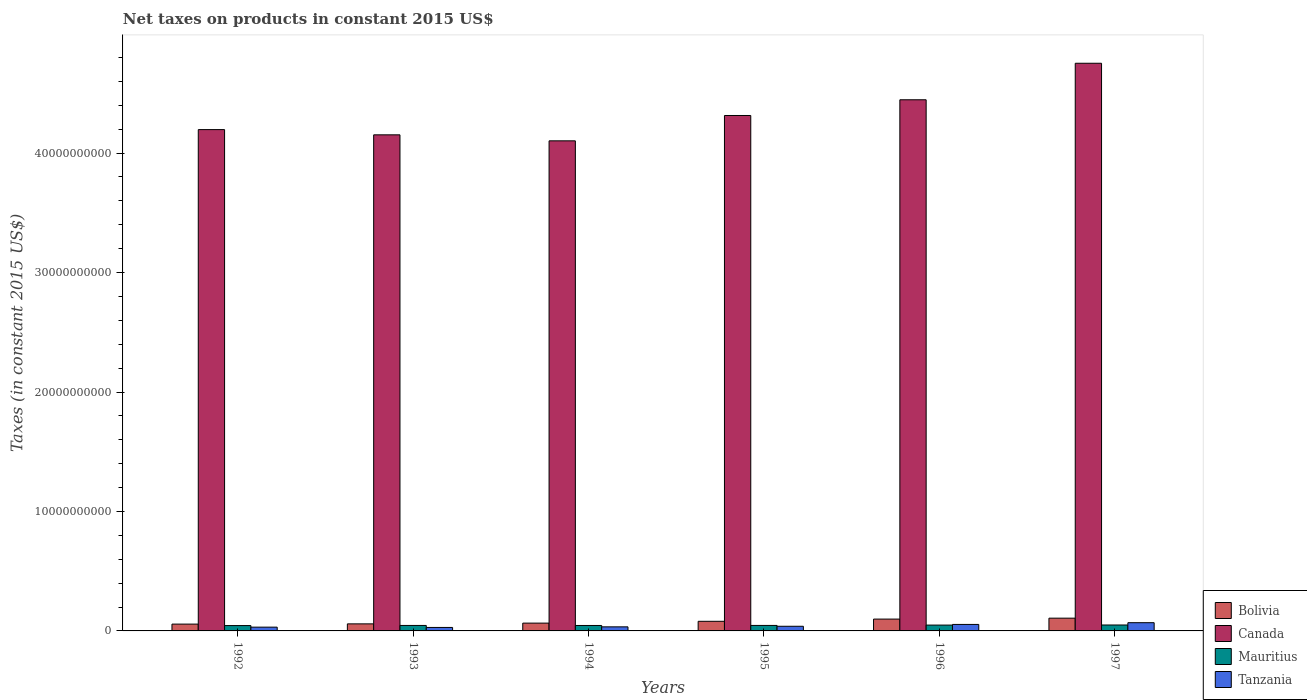How many groups of bars are there?
Your answer should be compact. 6. Are the number of bars on each tick of the X-axis equal?
Offer a very short reply. Yes. What is the label of the 6th group of bars from the left?
Ensure brevity in your answer.  1997. What is the net taxes on products in Bolivia in 1996?
Your answer should be compact. 9.90e+08. Across all years, what is the maximum net taxes on products in Mauritius?
Keep it short and to the point. 4.96e+08. Across all years, what is the minimum net taxes on products in Mauritius?
Provide a short and direct response. 4.48e+08. In which year was the net taxes on products in Bolivia maximum?
Your answer should be very brief. 1997. In which year was the net taxes on products in Bolivia minimum?
Offer a terse response. 1992. What is the total net taxes on products in Bolivia in the graph?
Your response must be concise. 4.68e+09. What is the difference between the net taxes on products in Bolivia in 1992 and that in 1997?
Keep it short and to the point. -4.96e+08. What is the difference between the net taxes on products in Mauritius in 1992 and the net taxes on products in Bolivia in 1997?
Your answer should be very brief. -6.20e+08. What is the average net taxes on products in Tanzania per year?
Provide a succinct answer. 4.28e+08. In the year 1997, what is the difference between the net taxes on products in Canada and net taxes on products in Tanzania?
Ensure brevity in your answer.  4.68e+1. In how many years, is the net taxes on products in Canada greater than 34000000000 US$?
Ensure brevity in your answer.  6. What is the ratio of the net taxes on products in Canada in 1994 to that in 1996?
Make the answer very short. 0.92. What is the difference between the highest and the second highest net taxes on products in Bolivia?
Provide a succinct answer. 7.73e+07. What is the difference between the highest and the lowest net taxes on products in Mauritius?
Keep it short and to the point. 4.88e+07. Is the sum of the net taxes on products in Mauritius in 1995 and 1996 greater than the maximum net taxes on products in Tanzania across all years?
Offer a very short reply. Yes. Is it the case that in every year, the sum of the net taxes on products in Tanzania and net taxes on products in Canada is greater than the sum of net taxes on products in Mauritius and net taxes on products in Bolivia?
Your response must be concise. Yes. What does the 2nd bar from the left in 1997 represents?
Your answer should be compact. Canada. Is it the case that in every year, the sum of the net taxes on products in Bolivia and net taxes on products in Tanzania is greater than the net taxes on products in Mauritius?
Provide a short and direct response. Yes. How many bars are there?
Ensure brevity in your answer.  24. Are all the bars in the graph horizontal?
Your response must be concise. No. What is the difference between two consecutive major ticks on the Y-axis?
Your answer should be compact. 1.00e+1. Does the graph contain any zero values?
Provide a succinct answer. No. Does the graph contain grids?
Your answer should be compact. No. Where does the legend appear in the graph?
Offer a very short reply. Bottom right. How are the legend labels stacked?
Give a very brief answer. Vertical. What is the title of the graph?
Keep it short and to the point. Net taxes on products in constant 2015 US$. What is the label or title of the Y-axis?
Give a very brief answer. Taxes (in constant 2015 US$). What is the Taxes (in constant 2015 US$) in Bolivia in 1992?
Your answer should be compact. 5.71e+08. What is the Taxes (in constant 2015 US$) of Canada in 1992?
Give a very brief answer. 4.20e+1. What is the Taxes (in constant 2015 US$) of Mauritius in 1992?
Give a very brief answer. 4.48e+08. What is the Taxes (in constant 2015 US$) in Tanzania in 1992?
Offer a terse response. 3.16e+08. What is the Taxes (in constant 2015 US$) in Bolivia in 1993?
Give a very brief answer. 5.90e+08. What is the Taxes (in constant 2015 US$) in Canada in 1993?
Your answer should be very brief. 4.15e+1. What is the Taxes (in constant 2015 US$) in Mauritius in 1993?
Your answer should be very brief. 4.58e+08. What is the Taxes (in constant 2015 US$) of Tanzania in 1993?
Ensure brevity in your answer.  2.91e+08. What is the Taxes (in constant 2015 US$) in Bolivia in 1994?
Your answer should be compact. 6.54e+08. What is the Taxes (in constant 2015 US$) in Canada in 1994?
Provide a short and direct response. 4.10e+1. What is the Taxes (in constant 2015 US$) in Mauritius in 1994?
Keep it short and to the point. 4.55e+08. What is the Taxes (in constant 2015 US$) of Tanzania in 1994?
Offer a very short reply. 3.41e+08. What is the Taxes (in constant 2015 US$) of Bolivia in 1995?
Ensure brevity in your answer.  8.05e+08. What is the Taxes (in constant 2015 US$) in Canada in 1995?
Keep it short and to the point. 4.31e+1. What is the Taxes (in constant 2015 US$) of Mauritius in 1995?
Keep it short and to the point. 4.59e+08. What is the Taxes (in constant 2015 US$) of Tanzania in 1995?
Ensure brevity in your answer.  3.89e+08. What is the Taxes (in constant 2015 US$) in Bolivia in 1996?
Your answer should be compact. 9.90e+08. What is the Taxes (in constant 2015 US$) of Canada in 1996?
Your response must be concise. 4.45e+1. What is the Taxes (in constant 2015 US$) of Mauritius in 1996?
Your answer should be compact. 4.89e+08. What is the Taxes (in constant 2015 US$) in Tanzania in 1996?
Keep it short and to the point. 5.43e+08. What is the Taxes (in constant 2015 US$) in Bolivia in 1997?
Offer a very short reply. 1.07e+09. What is the Taxes (in constant 2015 US$) of Canada in 1997?
Give a very brief answer. 4.75e+1. What is the Taxes (in constant 2015 US$) in Mauritius in 1997?
Provide a short and direct response. 4.96e+08. What is the Taxes (in constant 2015 US$) in Tanzania in 1997?
Ensure brevity in your answer.  6.89e+08. Across all years, what is the maximum Taxes (in constant 2015 US$) in Bolivia?
Provide a short and direct response. 1.07e+09. Across all years, what is the maximum Taxes (in constant 2015 US$) of Canada?
Provide a succinct answer. 4.75e+1. Across all years, what is the maximum Taxes (in constant 2015 US$) in Mauritius?
Ensure brevity in your answer.  4.96e+08. Across all years, what is the maximum Taxes (in constant 2015 US$) of Tanzania?
Your answer should be very brief. 6.89e+08. Across all years, what is the minimum Taxes (in constant 2015 US$) in Bolivia?
Your answer should be compact. 5.71e+08. Across all years, what is the minimum Taxes (in constant 2015 US$) of Canada?
Ensure brevity in your answer.  4.10e+1. Across all years, what is the minimum Taxes (in constant 2015 US$) in Mauritius?
Keep it short and to the point. 4.48e+08. Across all years, what is the minimum Taxes (in constant 2015 US$) of Tanzania?
Give a very brief answer. 2.91e+08. What is the total Taxes (in constant 2015 US$) in Bolivia in the graph?
Keep it short and to the point. 4.68e+09. What is the total Taxes (in constant 2015 US$) of Canada in the graph?
Keep it short and to the point. 2.60e+11. What is the total Taxes (in constant 2015 US$) in Mauritius in the graph?
Ensure brevity in your answer.  2.81e+09. What is the total Taxes (in constant 2015 US$) in Tanzania in the graph?
Offer a terse response. 2.57e+09. What is the difference between the Taxes (in constant 2015 US$) of Bolivia in 1992 and that in 1993?
Offer a very short reply. -1.90e+07. What is the difference between the Taxes (in constant 2015 US$) of Canada in 1992 and that in 1993?
Make the answer very short. 4.37e+08. What is the difference between the Taxes (in constant 2015 US$) of Mauritius in 1992 and that in 1993?
Offer a terse response. -1.08e+07. What is the difference between the Taxes (in constant 2015 US$) of Tanzania in 1992 and that in 1993?
Offer a terse response. 2.50e+07. What is the difference between the Taxes (in constant 2015 US$) of Bolivia in 1992 and that in 1994?
Provide a succinct answer. -8.23e+07. What is the difference between the Taxes (in constant 2015 US$) of Canada in 1992 and that in 1994?
Provide a succinct answer. 9.40e+08. What is the difference between the Taxes (in constant 2015 US$) of Mauritius in 1992 and that in 1994?
Your answer should be compact. -7.79e+06. What is the difference between the Taxes (in constant 2015 US$) in Tanzania in 1992 and that in 1994?
Your response must be concise. -2.49e+07. What is the difference between the Taxes (in constant 2015 US$) in Bolivia in 1992 and that in 1995?
Provide a short and direct response. -2.34e+08. What is the difference between the Taxes (in constant 2015 US$) in Canada in 1992 and that in 1995?
Your response must be concise. -1.18e+09. What is the difference between the Taxes (in constant 2015 US$) in Mauritius in 1992 and that in 1995?
Offer a terse response. -1.19e+07. What is the difference between the Taxes (in constant 2015 US$) of Tanzania in 1992 and that in 1995?
Give a very brief answer. -7.39e+07. What is the difference between the Taxes (in constant 2015 US$) in Bolivia in 1992 and that in 1996?
Ensure brevity in your answer.  -4.19e+08. What is the difference between the Taxes (in constant 2015 US$) of Canada in 1992 and that in 1996?
Offer a terse response. -2.50e+09. What is the difference between the Taxes (in constant 2015 US$) of Mauritius in 1992 and that in 1996?
Give a very brief answer. -4.10e+07. What is the difference between the Taxes (in constant 2015 US$) in Tanzania in 1992 and that in 1996?
Provide a succinct answer. -2.28e+08. What is the difference between the Taxes (in constant 2015 US$) of Bolivia in 1992 and that in 1997?
Provide a short and direct response. -4.96e+08. What is the difference between the Taxes (in constant 2015 US$) of Canada in 1992 and that in 1997?
Offer a very short reply. -5.55e+09. What is the difference between the Taxes (in constant 2015 US$) of Mauritius in 1992 and that in 1997?
Your response must be concise. -4.88e+07. What is the difference between the Taxes (in constant 2015 US$) of Tanzania in 1992 and that in 1997?
Ensure brevity in your answer.  -3.74e+08. What is the difference between the Taxes (in constant 2015 US$) of Bolivia in 1993 and that in 1994?
Your response must be concise. -6.34e+07. What is the difference between the Taxes (in constant 2015 US$) of Canada in 1993 and that in 1994?
Provide a short and direct response. 5.03e+08. What is the difference between the Taxes (in constant 2015 US$) in Mauritius in 1993 and that in 1994?
Your response must be concise. 2.97e+06. What is the difference between the Taxes (in constant 2015 US$) in Tanzania in 1993 and that in 1994?
Your answer should be compact. -4.99e+07. What is the difference between the Taxes (in constant 2015 US$) of Bolivia in 1993 and that in 1995?
Keep it short and to the point. -2.15e+08. What is the difference between the Taxes (in constant 2015 US$) of Canada in 1993 and that in 1995?
Your answer should be compact. -1.62e+09. What is the difference between the Taxes (in constant 2015 US$) in Mauritius in 1993 and that in 1995?
Keep it short and to the point. -1.11e+06. What is the difference between the Taxes (in constant 2015 US$) of Tanzania in 1993 and that in 1995?
Give a very brief answer. -9.89e+07. What is the difference between the Taxes (in constant 2015 US$) of Bolivia in 1993 and that in 1996?
Provide a succinct answer. -4.00e+08. What is the difference between the Taxes (in constant 2015 US$) in Canada in 1993 and that in 1996?
Your answer should be very brief. -2.93e+09. What is the difference between the Taxes (in constant 2015 US$) of Mauritius in 1993 and that in 1996?
Offer a terse response. -3.02e+07. What is the difference between the Taxes (in constant 2015 US$) of Tanzania in 1993 and that in 1996?
Make the answer very short. -2.53e+08. What is the difference between the Taxes (in constant 2015 US$) in Bolivia in 1993 and that in 1997?
Provide a succinct answer. -4.77e+08. What is the difference between the Taxes (in constant 2015 US$) of Canada in 1993 and that in 1997?
Make the answer very short. -5.99e+09. What is the difference between the Taxes (in constant 2015 US$) in Mauritius in 1993 and that in 1997?
Make the answer very short. -3.80e+07. What is the difference between the Taxes (in constant 2015 US$) of Tanzania in 1993 and that in 1997?
Your answer should be compact. -3.99e+08. What is the difference between the Taxes (in constant 2015 US$) of Bolivia in 1994 and that in 1995?
Provide a short and direct response. -1.51e+08. What is the difference between the Taxes (in constant 2015 US$) of Canada in 1994 and that in 1995?
Offer a very short reply. -2.12e+09. What is the difference between the Taxes (in constant 2015 US$) in Mauritius in 1994 and that in 1995?
Provide a succinct answer. -4.07e+06. What is the difference between the Taxes (in constant 2015 US$) of Tanzania in 1994 and that in 1995?
Offer a terse response. -4.90e+07. What is the difference between the Taxes (in constant 2015 US$) in Bolivia in 1994 and that in 1996?
Offer a very short reply. -3.37e+08. What is the difference between the Taxes (in constant 2015 US$) in Canada in 1994 and that in 1996?
Offer a terse response. -3.44e+09. What is the difference between the Taxes (in constant 2015 US$) of Mauritius in 1994 and that in 1996?
Offer a very short reply. -3.32e+07. What is the difference between the Taxes (in constant 2015 US$) in Tanzania in 1994 and that in 1996?
Offer a very short reply. -2.03e+08. What is the difference between the Taxes (in constant 2015 US$) of Bolivia in 1994 and that in 1997?
Provide a succinct answer. -4.14e+08. What is the difference between the Taxes (in constant 2015 US$) of Canada in 1994 and that in 1997?
Provide a short and direct response. -6.49e+09. What is the difference between the Taxes (in constant 2015 US$) in Mauritius in 1994 and that in 1997?
Offer a terse response. -4.10e+07. What is the difference between the Taxes (in constant 2015 US$) of Tanzania in 1994 and that in 1997?
Provide a short and direct response. -3.49e+08. What is the difference between the Taxes (in constant 2015 US$) in Bolivia in 1995 and that in 1996?
Provide a succinct answer. -1.85e+08. What is the difference between the Taxes (in constant 2015 US$) of Canada in 1995 and that in 1996?
Offer a very short reply. -1.32e+09. What is the difference between the Taxes (in constant 2015 US$) in Mauritius in 1995 and that in 1996?
Offer a very short reply. -2.91e+07. What is the difference between the Taxes (in constant 2015 US$) in Tanzania in 1995 and that in 1996?
Give a very brief answer. -1.54e+08. What is the difference between the Taxes (in constant 2015 US$) of Bolivia in 1995 and that in 1997?
Give a very brief answer. -2.62e+08. What is the difference between the Taxes (in constant 2015 US$) of Canada in 1995 and that in 1997?
Make the answer very short. -4.37e+09. What is the difference between the Taxes (in constant 2015 US$) of Mauritius in 1995 and that in 1997?
Keep it short and to the point. -3.69e+07. What is the difference between the Taxes (in constant 2015 US$) of Tanzania in 1995 and that in 1997?
Provide a short and direct response. -3.00e+08. What is the difference between the Taxes (in constant 2015 US$) of Bolivia in 1996 and that in 1997?
Keep it short and to the point. -7.73e+07. What is the difference between the Taxes (in constant 2015 US$) of Canada in 1996 and that in 1997?
Your answer should be compact. -3.06e+09. What is the difference between the Taxes (in constant 2015 US$) of Mauritius in 1996 and that in 1997?
Offer a very short reply. -7.79e+06. What is the difference between the Taxes (in constant 2015 US$) of Tanzania in 1996 and that in 1997?
Provide a short and direct response. -1.46e+08. What is the difference between the Taxes (in constant 2015 US$) of Bolivia in 1992 and the Taxes (in constant 2015 US$) of Canada in 1993?
Provide a short and direct response. -4.10e+1. What is the difference between the Taxes (in constant 2015 US$) of Bolivia in 1992 and the Taxes (in constant 2015 US$) of Mauritius in 1993?
Give a very brief answer. 1.13e+08. What is the difference between the Taxes (in constant 2015 US$) in Bolivia in 1992 and the Taxes (in constant 2015 US$) in Tanzania in 1993?
Make the answer very short. 2.81e+08. What is the difference between the Taxes (in constant 2015 US$) in Canada in 1992 and the Taxes (in constant 2015 US$) in Mauritius in 1993?
Give a very brief answer. 4.15e+1. What is the difference between the Taxes (in constant 2015 US$) in Canada in 1992 and the Taxes (in constant 2015 US$) in Tanzania in 1993?
Provide a short and direct response. 4.17e+1. What is the difference between the Taxes (in constant 2015 US$) in Mauritius in 1992 and the Taxes (in constant 2015 US$) in Tanzania in 1993?
Keep it short and to the point. 1.57e+08. What is the difference between the Taxes (in constant 2015 US$) of Bolivia in 1992 and the Taxes (in constant 2015 US$) of Canada in 1994?
Your answer should be compact. -4.05e+1. What is the difference between the Taxes (in constant 2015 US$) in Bolivia in 1992 and the Taxes (in constant 2015 US$) in Mauritius in 1994?
Your answer should be compact. 1.16e+08. What is the difference between the Taxes (in constant 2015 US$) in Bolivia in 1992 and the Taxes (in constant 2015 US$) in Tanzania in 1994?
Ensure brevity in your answer.  2.31e+08. What is the difference between the Taxes (in constant 2015 US$) in Canada in 1992 and the Taxes (in constant 2015 US$) in Mauritius in 1994?
Your response must be concise. 4.15e+1. What is the difference between the Taxes (in constant 2015 US$) in Canada in 1992 and the Taxes (in constant 2015 US$) in Tanzania in 1994?
Give a very brief answer. 4.16e+1. What is the difference between the Taxes (in constant 2015 US$) of Mauritius in 1992 and the Taxes (in constant 2015 US$) of Tanzania in 1994?
Keep it short and to the point. 1.07e+08. What is the difference between the Taxes (in constant 2015 US$) in Bolivia in 1992 and the Taxes (in constant 2015 US$) in Canada in 1995?
Ensure brevity in your answer.  -4.26e+1. What is the difference between the Taxes (in constant 2015 US$) in Bolivia in 1992 and the Taxes (in constant 2015 US$) in Mauritius in 1995?
Your response must be concise. 1.12e+08. What is the difference between the Taxes (in constant 2015 US$) in Bolivia in 1992 and the Taxes (in constant 2015 US$) in Tanzania in 1995?
Your response must be concise. 1.82e+08. What is the difference between the Taxes (in constant 2015 US$) in Canada in 1992 and the Taxes (in constant 2015 US$) in Mauritius in 1995?
Keep it short and to the point. 4.15e+1. What is the difference between the Taxes (in constant 2015 US$) in Canada in 1992 and the Taxes (in constant 2015 US$) in Tanzania in 1995?
Keep it short and to the point. 4.16e+1. What is the difference between the Taxes (in constant 2015 US$) in Mauritius in 1992 and the Taxes (in constant 2015 US$) in Tanzania in 1995?
Keep it short and to the point. 5.81e+07. What is the difference between the Taxes (in constant 2015 US$) of Bolivia in 1992 and the Taxes (in constant 2015 US$) of Canada in 1996?
Provide a succinct answer. -4.39e+1. What is the difference between the Taxes (in constant 2015 US$) of Bolivia in 1992 and the Taxes (in constant 2015 US$) of Mauritius in 1996?
Give a very brief answer. 8.29e+07. What is the difference between the Taxes (in constant 2015 US$) in Bolivia in 1992 and the Taxes (in constant 2015 US$) in Tanzania in 1996?
Your answer should be very brief. 2.82e+07. What is the difference between the Taxes (in constant 2015 US$) of Canada in 1992 and the Taxes (in constant 2015 US$) of Mauritius in 1996?
Your answer should be very brief. 4.15e+1. What is the difference between the Taxes (in constant 2015 US$) of Canada in 1992 and the Taxes (in constant 2015 US$) of Tanzania in 1996?
Keep it short and to the point. 4.14e+1. What is the difference between the Taxes (in constant 2015 US$) of Mauritius in 1992 and the Taxes (in constant 2015 US$) of Tanzania in 1996?
Your answer should be compact. -9.57e+07. What is the difference between the Taxes (in constant 2015 US$) of Bolivia in 1992 and the Taxes (in constant 2015 US$) of Canada in 1997?
Make the answer very short. -4.69e+1. What is the difference between the Taxes (in constant 2015 US$) in Bolivia in 1992 and the Taxes (in constant 2015 US$) in Mauritius in 1997?
Your answer should be very brief. 7.51e+07. What is the difference between the Taxes (in constant 2015 US$) in Bolivia in 1992 and the Taxes (in constant 2015 US$) in Tanzania in 1997?
Your answer should be compact. -1.18e+08. What is the difference between the Taxes (in constant 2015 US$) of Canada in 1992 and the Taxes (in constant 2015 US$) of Mauritius in 1997?
Give a very brief answer. 4.15e+1. What is the difference between the Taxes (in constant 2015 US$) of Canada in 1992 and the Taxes (in constant 2015 US$) of Tanzania in 1997?
Ensure brevity in your answer.  4.13e+1. What is the difference between the Taxes (in constant 2015 US$) of Mauritius in 1992 and the Taxes (in constant 2015 US$) of Tanzania in 1997?
Provide a short and direct response. -2.42e+08. What is the difference between the Taxes (in constant 2015 US$) in Bolivia in 1993 and the Taxes (in constant 2015 US$) in Canada in 1994?
Give a very brief answer. -4.04e+1. What is the difference between the Taxes (in constant 2015 US$) in Bolivia in 1993 and the Taxes (in constant 2015 US$) in Mauritius in 1994?
Your response must be concise. 1.35e+08. What is the difference between the Taxes (in constant 2015 US$) of Bolivia in 1993 and the Taxes (in constant 2015 US$) of Tanzania in 1994?
Keep it short and to the point. 2.50e+08. What is the difference between the Taxes (in constant 2015 US$) in Canada in 1993 and the Taxes (in constant 2015 US$) in Mauritius in 1994?
Provide a succinct answer. 4.11e+1. What is the difference between the Taxes (in constant 2015 US$) in Canada in 1993 and the Taxes (in constant 2015 US$) in Tanzania in 1994?
Offer a terse response. 4.12e+1. What is the difference between the Taxes (in constant 2015 US$) of Mauritius in 1993 and the Taxes (in constant 2015 US$) of Tanzania in 1994?
Keep it short and to the point. 1.18e+08. What is the difference between the Taxes (in constant 2015 US$) in Bolivia in 1993 and the Taxes (in constant 2015 US$) in Canada in 1995?
Ensure brevity in your answer.  -4.26e+1. What is the difference between the Taxes (in constant 2015 US$) in Bolivia in 1993 and the Taxes (in constant 2015 US$) in Mauritius in 1995?
Offer a very short reply. 1.31e+08. What is the difference between the Taxes (in constant 2015 US$) of Bolivia in 1993 and the Taxes (in constant 2015 US$) of Tanzania in 1995?
Ensure brevity in your answer.  2.01e+08. What is the difference between the Taxes (in constant 2015 US$) of Canada in 1993 and the Taxes (in constant 2015 US$) of Mauritius in 1995?
Your response must be concise. 4.11e+1. What is the difference between the Taxes (in constant 2015 US$) in Canada in 1993 and the Taxes (in constant 2015 US$) in Tanzania in 1995?
Offer a terse response. 4.11e+1. What is the difference between the Taxes (in constant 2015 US$) in Mauritius in 1993 and the Taxes (in constant 2015 US$) in Tanzania in 1995?
Offer a very short reply. 6.88e+07. What is the difference between the Taxes (in constant 2015 US$) in Bolivia in 1993 and the Taxes (in constant 2015 US$) in Canada in 1996?
Give a very brief answer. -4.39e+1. What is the difference between the Taxes (in constant 2015 US$) of Bolivia in 1993 and the Taxes (in constant 2015 US$) of Mauritius in 1996?
Make the answer very short. 1.02e+08. What is the difference between the Taxes (in constant 2015 US$) of Bolivia in 1993 and the Taxes (in constant 2015 US$) of Tanzania in 1996?
Offer a very short reply. 4.71e+07. What is the difference between the Taxes (in constant 2015 US$) of Canada in 1993 and the Taxes (in constant 2015 US$) of Mauritius in 1996?
Make the answer very short. 4.10e+1. What is the difference between the Taxes (in constant 2015 US$) in Canada in 1993 and the Taxes (in constant 2015 US$) in Tanzania in 1996?
Your response must be concise. 4.10e+1. What is the difference between the Taxes (in constant 2015 US$) in Mauritius in 1993 and the Taxes (in constant 2015 US$) in Tanzania in 1996?
Your answer should be compact. -8.50e+07. What is the difference between the Taxes (in constant 2015 US$) in Bolivia in 1993 and the Taxes (in constant 2015 US$) in Canada in 1997?
Offer a very short reply. -4.69e+1. What is the difference between the Taxes (in constant 2015 US$) of Bolivia in 1993 and the Taxes (in constant 2015 US$) of Mauritius in 1997?
Keep it short and to the point. 9.41e+07. What is the difference between the Taxes (in constant 2015 US$) in Bolivia in 1993 and the Taxes (in constant 2015 US$) in Tanzania in 1997?
Your answer should be very brief. -9.88e+07. What is the difference between the Taxes (in constant 2015 US$) in Canada in 1993 and the Taxes (in constant 2015 US$) in Mauritius in 1997?
Your answer should be very brief. 4.10e+1. What is the difference between the Taxes (in constant 2015 US$) in Canada in 1993 and the Taxes (in constant 2015 US$) in Tanzania in 1997?
Provide a succinct answer. 4.08e+1. What is the difference between the Taxes (in constant 2015 US$) in Mauritius in 1993 and the Taxes (in constant 2015 US$) in Tanzania in 1997?
Your answer should be compact. -2.31e+08. What is the difference between the Taxes (in constant 2015 US$) in Bolivia in 1994 and the Taxes (in constant 2015 US$) in Canada in 1995?
Make the answer very short. -4.25e+1. What is the difference between the Taxes (in constant 2015 US$) of Bolivia in 1994 and the Taxes (in constant 2015 US$) of Mauritius in 1995?
Ensure brevity in your answer.  1.94e+08. What is the difference between the Taxes (in constant 2015 US$) in Bolivia in 1994 and the Taxes (in constant 2015 US$) in Tanzania in 1995?
Keep it short and to the point. 2.64e+08. What is the difference between the Taxes (in constant 2015 US$) in Canada in 1994 and the Taxes (in constant 2015 US$) in Mauritius in 1995?
Provide a succinct answer. 4.06e+1. What is the difference between the Taxes (in constant 2015 US$) of Canada in 1994 and the Taxes (in constant 2015 US$) of Tanzania in 1995?
Your answer should be compact. 4.06e+1. What is the difference between the Taxes (in constant 2015 US$) of Mauritius in 1994 and the Taxes (in constant 2015 US$) of Tanzania in 1995?
Your answer should be very brief. 6.58e+07. What is the difference between the Taxes (in constant 2015 US$) in Bolivia in 1994 and the Taxes (in constant 2015 US$) in Canada in 1996?
Offer a very short reply. -4.38e+1. What is the difference between the Taxes (in constant 2015 US$) of Bolivia in 1994 and the Taxes (in constant 2015 US$) of Mauritius in 1996?
Keep it short and to the point. 1.65e+08. What is the difference between the Taxes (in constant 2015 US$) of Bolivia in 1994 and the Taxes (in constant 2015 US$) of Tanzania in 1996?
Keep it short and to the point. 1.10e+08. What is the difference between the Taxes (in constant 2015 US$) in Canada in 1994 and the Taxes (in constant 2015 US$) in Mauritius in 1996?
Provide a succinct answer. 4.05e+1. What is the difference between the Taxes (in constant 2015 US$) in Canada in 1994 and the Taxes (in constant 2015 US$) in Tanzania in 1996?
Offer a very short reply. 4.05e+1. What is the difference between the Taxes (in constant 2015 US$) in Mauritius in 1994 and the Taxes (in constant 2015 US$) in Tanzania in 1996?
Make the answer very short. -8.79e+07. What is the difference between the Taxes (in constant 2015 US$) in Bolivia in 1994 and the Taxes (in constant 2015 US$) in Canada in 1997?
Your answer should be very brief. -4.69e+1. What is the difference between the Taxes (in constant 2015 US$) in Bolivia in 1994 and the Taxes (in constant 2015 US$) in Mauritius in 1997?
Your answer should be very brief. 1.57e+08. What is the difference between the Taxes (in constant 2015 US$) in Bolivia in 1994 and the Taxes (in constant 2015 US$) in Tanzania in 1997?
Offer a terse response. -3.54e+07. What is the difference between the Taxes (in constant 2015 US$) of Canada in 1994 and the Taxes (in constant 2015 US$) of Mauritius in 1997?
Your answer should be compact. 4.05e+1. What is the difference between the Taxes (in constant 2015 US$) of Canada in 1994 and the Taxes (in constant 2015 US$) of Tanzania in 1997?
Provide a short and direct response. 4.03e+1. What is the difference between the Taxes (in constant 2015 US$) in Mauritius in 1994 and the Taxes (in constant 2015 US$) in Tanzania in 1997?
Make the answer very short. -2.34e+08. What is the difference between the Taxes (in constant 2015 US$) in Bolivia in 1995 and the Taxes (in constant 2015 US$) in Canada in 1996?
Your answer should be very brief. -4.37e+1. What is the difference between the Taxes (in constant 2015 US$) of Bolivia in 1995 and the Taxes (in constant 2015 US$) of Mauritius in 1996?
Your response must be concise. 3.17e+08. What is the difference between the Taxes (in constant 2015 US$) in Bolivia in 1995 and the Taxes (in constant 2015 US$) in Tanzania in 1996?
Ensure brevity in your answer.  2.62e+08. What is the difference between the Taxes (in constant 2015 US$) in Canada in 1995 and the Taxes (in constant 2015 US$) in Mauritius in 1996?
Provide a short and direct response. 4.27e+1. What is the difference between the Taxes (in constant 2015 US$) of Canada in 1995 and the Taxes (in constant 2015 US$) of Tanzania in 1996?
Keep it short and to the point. 4.26e+1. What is the difference between the Taxes (in constant 2015 US$) in Mauritius in 1995 and the Taxes (in constant 2015 US$) in Tanzania in 1996?
Make the answer very short. -8.39e+07. What is the difference between the Taxes (in constant 2015 US$) of Bolivia in 1995 and the Taxes (in constant 2015 US$) of Canada in 1997?
Your response must be concise. -4.67e+1. What is the difference between the Taxes (in constant 2015 US$) of Bolivia in 1995 and the Taxes (in constant 2015 US$) of Mauritius in 1997?
Offer a very short reply. 3.09e+08. What is the difference between the Taxes (in constant 2015 US$) in Bolivia in 1995 and the Taxes (in constant 2015 US$) in Tanzania in 1997?
Give a very brief answer. 1.16e+08. What is the difference between the Taxes (in constant 2015 US$) of Canada in 1995 and the Taxes (in constant 2015 US$) of Mauritius in 1997?
Keep it short and to the point. 4.26e+1. What is the difference between the Taxes (in constant 2015 US$) of Canada in 1995 and the Taxes (in constant 2015 US$) of Tanzania in 1997?
Offer a terse response. 4.25e+1. What is the difference between the Taxes (in constant 2015 US$) in Mauritius in 1995 and the Taxes (in constant 2015 US$) in Tanzania in 1997?
Give a very brief answer. -2.30e+08. What is the difference between the Taxes (in constant 2015 US$) in Bolivia in 1996 and the Taxes (in constant 2015 US$) in Canada in 1997?
Give a very brief answer. -4.65e+1. What is the difference between the Taxes (in constant 2015 US$) in Bolivia in 1996 and the Taxes (in constant 2015 US$) in Mauritius in 1997?
Your response must be concise. 4.94e+08. What is the difference between the Taxes (in constant 2015 US$) in Bolivia in 1996 and the Taxes (in constant 2015 US$) in Tanzania in 1997?
Your response must be concise. 3.01e+08. What is the difference between the Taxes (in constant 2015 US$) of Canada in 1996 and the Taxes (in constant 2015 US$) of Mauritius in 1997?
Keep it short and to the point. 4.40e+1. What is the difference between the Taxes (in constant 2015 US$) of Canada in 1996 and the Taxes (in constant 2015 US$) of Tanzania in 1997?
Make the answer very short. 4.38e+1. What is the difference between the Taxes (in constant 2015 US$) in Mauritius in 1996 and the Taxes (in constant 2015 US$) in Tanzania in 1997?
Your answer should be very brief. -2.01e+08. What is the average Taxes (in constant 2015 US$) of Bolivia per year?
Provide a short and direct response. 7.80e+08. What is the average Taxes (in constant 2015 US$) in Canada per year?
Give a very brief answer. 4.33e+1. What is the average Taxes (in constant 2015 US$) in Mauritius per year?
Provide a succinct answer. 4.68e+08. What is the average Taxes (in constant 2015 US$) of Tanzania per year?
Offer a very short reply. 4.28e+08. In the year 1992, what is the difference between the Taxes (in constant 2015 US$) of Bolivia and Taxes (in constant 2015 US$) of Canada?
Offer a terse response. -4.14e+1. In the year 1992, what is the difference between the Taxes (in constant 2015 US$) of Bolivia and Taxes (in constant 2015 US$) of Mauritius?
Give a very brief answer. 1.24e+08. In the year 1992, what is the difference between the Taxes (in constant 2015 US$) in Bolivia and Taxes (in constant 2015 US$) in Tanzania?
Make the answer very short. 2.56e+08. In the year 1992, what is the difference between the Taxes (in constant 2015 US$) of Canada and Taxes (in constant 2015 US$) of Mauritius?
Make the answer very short. 4.15e+1. In the year 1992, what is the difference between the Taxes (in constant 2015 US$) of Canada and Taxes (in constant 2015 US$) of Tanzania?
Provide a short and direct response. 4.16e+1. In the year 1992, what is the difference between the Taxes (in constant 2015 US$) of Mauritius and Taxes (in constant 2015 US$) of Tanzania?
Your answer should be very brief. 1.32e+08. In the year 1993, what is the difference between the Taxes (in constant 2015 US$) in Bolivia and Taxes (in constant 2015 US$) in Canada?
Offer a terse response. -4.09e+1. In the year 1993, what is the difference between the Taxes (in constant 2015 US$) of Bolivia and Taxes (in constant 2015 US$) of Mauritius?
Ensure brevity in your answer.  1.32e+08. In the year 1993, what is the difference between the Taxes (in constant 2015 US$) of Bolivia and Taxes (in constant 2015 US$) of Tanzania?
Give a very brief answer. 3.00e+08. In the year 1993, what is the difference between the Taxes (in constant 2015 US$) in Canada and Taxes (in constant 2015 US$) in Mauritius?
Make the answer very short. 4.11e+1. In the year 1993, what is the difference between the Taxes (in constant 2015 US$) of Canada and Taxes (in constant 2015 US$) of Tanzania?
Make the answer very short. 4.12e+1. In the year 1993, what is the difference between the Taxes (in constant 2015 US$) of Mauritius and Taxes (in constant 2015 US$) of Tanzania?
Ensure brevity in your answer.  1.68e+08. In the year 1994, what is the difference between the Taxes (in constant 2015 US$) of Bolivia and Taxes (in constant 2015 US$) of Canada?
Give a very brief answer. -4.04e+1. In the year 1994, what is the difference between the Taxes (in constant 2015 US$) of Bolivia and Taxes (in constant 2015 US$) of Mauritius?
Provide a short and direct response. 1.98e+08. In the year 1994, what is the difference between the Taxes (in constant 2015 US$) in Bolivia and Taxes (in constant 2015 US$) in Tanzania?
Offer a very short reply. 3.13e+08. In the year 1994, what is the difference between the Taxes (in constant 2015 US$) in Canada and Taxes (in constant 2015 US$) in Mauritius?
Give a very brief answer. 4.06e+1. In the year 1994, what is the difference between the Taxes (in constant 2015 US$) of Canada and Taxes (in constant 2015 US$) of Tanzania?
Offer a terse response. 4.07e+1. In the year 1994, what is the difference between the Taxes (in constant 2015 US$) in Mauritius and Taxes (in constant 2015 US$) in Tanzania?
Your answer should be compact. 1.15e+08. In the year 1995, what is the difference between the Taxes (in constant 2015 US$) of Bolivia and Taxes (in constant 2015 US$) of Canada?
Offer a terse response. -4.23e+1. In the year 1995, what is the difference between the Taxes (in constant 2015 US$) of Bolivia and Taxes (in constant 2015 US$) of Mauritius?
Your response must be concise. 3.46e+08. In the year 1995, what is the difference between the Taxes (in constant 2015 US$) in Bolivia and Taxes (in constant 2015 US$) in Tanzania?
Keep it short and to the point. 4.16e+08. In the year 1995, what is the difference between the Taxes (in constant 2015 US$) in Canada and Taxes (in constant 2015 US$) in Mauritius?
Give a very brief answer. 4.27e+1. In the year 1995, what is the difference between the Taxes (in constant 2015 US$) of Canada and Taxes (in constant 2015 US$) of Tanzania?
Make the answer very short. 4.28e+1. In the year 1995, what is the difference between the Taxes (in constant 2015 US$) of Mauritius and Taxes (in constant 2015 US$) of Tanzania?
Offer a very short reply. 6.99e+07. In the year 1996, what is the difference between the Taxes (in constant 2015 US$) in Bolivia and Taxes (in constant 2015 US$) in Canada?
Keep it short and to the point. -4.35e+1. In the year 1996, what is the difference between the Taxes (in constant 2015 US$) of Bolivia and Taxes (in constant 2015 US$) of Mauritius?
Ensure brevity in your answer.  5.02e+08. In the year 1996, what is the difference between the Taxes (in constant 2015 US$) of Bolivia and Taxes (in constant 2015 US$) of Tanzania?
Provide a short and direct response. 4.47e+08. In the year 1996, what is the difference between the Taxes (in constant 2015 US$) of Canada and Taxes (in constant 2015 US$) of Mauritius?
Your answer should be compact. 4.40e+1. In the year 1996, what is the difference between the Taxes (in constant 2015 US$) in Canada and Taxes (in constant 2015 US$) in Tanzania?
Give a very brief answer. 4.39e+1. In the year 1996, what is the difference between the Taxes (in constant 2015 US$) in Mauritius and Taxes (in constant 2015 US$) in Tanzania?
Keep it short and to the point. -5.47e+07. In the year 1997, what is the difference between the Taxes (in constant 2015 US$) in Bolivia and Taxes (in constant 2015 US$) in Canada?
Ensure brevity in your answer.  -4.65e+1. In the year 1997, what is the difference between the Taxes (in constant 2015 US$) of Bolivia and Taxes (in constant 2015 US$) of Mauritius?
Your answer should be compact. 5.71e+08. In the year 1997, what is the difference between the Taxes (in constant 2015 US$) of Bolivia and Taxes (in constant 2015 US$) of Tanzania?
Your answer should be very brief. 3.78e+08. In the year 1997, what is the difference between the Taxes (in constant 2015 US$) in Canada and Taxes (in constant 2015 US$) in Mauritius?
Ensure brevity in your answer.  4.70e+1. In the year 1997, what is the difference between the Taxes (in constant 2015 US$) of Canada and Taxes (in constant 2015 US$) of Tanzania?
Offer a very short reply. 4.68e+1. In the year 1997, what is the difference between the Taxes (in constant 2015 US$) of Mauritius and Taxes (in constant 2015 US$) of Tanzania?
Give a very brief answer. -1.93e+08. What is the ratio of the Taxes (in constant 2015 US$) of Bolivia in 1992 to that in 1993?
Your response must be concise. 0.97. What is the ratio of the Taxes (in constant 2015 US$) of Canada in 1992 to that in 1993?
Offer a terse response. 1.01. What is the ratio of the Taxes (in constant 2015 US$) of Mauritius in 1992 to that in 1993?
Your response must be concise. 0.98. What is the ratio of the Taxes (in constant 2015 US$) of Tanzania in 1992 to that in 1993?
Offer a very short reply. 1.09. What is the ratio of the Taxes (in constant 2015 US$) of Bolivia in 1992 to that in 1994?
Make the answer very short. 0.87. What is the ratio of the Taxes (in constant 2015 US$) in Canada in 1992 to that in 1994?
Make the answer very short. 1.02. What is the ratio of the Taxes (in constant 2015 US$) of Mauritius in 1992 to that in 1994?
Offer a very short reply. 0.98. What is the ratio of the Taxes (in constant 2015 US$) of Tanzania in 1992 to that in 1994?
Offer a terse response. 0.93. What is the ratio of the Taxes (in constant 2015 US$) in Bolivia in 1992 to that in 1995?
Offer a terse response. 0.71. What is the ratio of the Taxes (in constant 2015 US$) of Canada in 1992 to that in 1995?
Provide a succinct answer. 0.97. What is the ratio of the Taxes (in constant 2015 US$) of Mauritius in 1992 to that in 1995?
Offer a very short reply. 0.97. What is the ratio of the Taxes (in constant 2015 US$) of Tanzania in 1992 to that in 1995?
Offer a very short reply. 0.81. What is the ratio of the Taxes (in constant 2015 US$) in Bolivia in 1992 to that in 1996?
Offer a terse response. 0.58. What is the ratio of the Taxes (in constant 2015 US$) of Canada in 1992 to that in 1996?
Give a very brief answer. 0.94. What is the ratio of the Taxes (in constant 2015 US$) of Mauritius in 1992 to that in 1996?
Provide a short and direct response. 0.92. What is the ratio of the Taxes (in constant 2015 US$) in Tanzania in 1992 to that in 1996?
Your response must be concise. 0.58. What is the ratio of the Taxes (in constant 2015 US$) in Bolivia in 1992 to that in 1997?
Keep it short and to the point. 0.54. What is the ratio of the Taxes (in constant 2015 US$) in Canada in 1992 to that in 1997?
Ensure brevity in your answer.  0.88. What is the ratio of the Taxes (in constant 2015 US$) in Mauritius in 1992 to that in 1997?
Provide a succinct answer. 0.9. What is the ratio of the Taxes (in constant 2015 US$) in Tanzania in 1992 to that in 1997?
Give a very brief answer. 0.46. What is the ratio of the Taxes (in constant 2015 US$) in Bolivia in 1993 to that in 1994?
Offer a very short reply. 0.9. What is the ratio of the Taxes (in constant 2015 US$) in Canada in 1993 to that in 1994?
Ensure brevity in your answer.  1.01. What is the ratio of the Taxes (in constant 2015 US$) in Tanzania in 1993 to that in 1994?
Give a very brief answer. 0.85. What is the ratio of the Taxes (in constant 2015 US$) of Bolivia in 1993 to that in 1995?
Your response must be concise. 0.73. What is the ratio of the Taxes (in constant 2015 US$) in Canada in 1993 to that in 1995?
Your answer should be very brief. 0.96. What is the ratio of the Taxes (in constant 2015 US$) in Mauritius in 1993 to that in 1995?
Keep it short and to the point. 1. What is the ratio of the Taxes (in constant 2015 US$) in Tanzania in 1993 to that in 1995?
Make the answer very short. 0.75. What is the ratio of the Taxes (in constant 2015 US$) of Bolivia in 1993 to that in 1996?
Ensure brevity in your answer.  0.6. What is the ratio of the Taxes (in constant 2015 US$) of Canada in 1993 to that in 1996?
Your response must be concise. 0.93. What is the ratio of the Taxes (in constant 2015 US$) of Mauritius in 1993 to that in 1996?
Your answer should be compact. 0.94. What is the ratio of the Taxes (in constant 2015 US$) in Tanzania in 1993 to that in 1996?
Ensure brevity in your answer.  0.53. What is the ratio of the Taxes (in constant 2015 US$) of Bolivia in 1993 to that in 1997?
Give a very brief answer. 0.55. What is the ratio of the Taxes (in constant 2015 US$) of Canada in 1993 to that in 1997?
Give a very brief answer. 0.87. What is the ratio of the Taxes (in constant 2015 US$) in Mauritius in 1993 to that in 1997?
Give a very brief answer. 0.92. What is the ratio of the Taxes (in constant 2015 US$) of Tanzania in 1993 to that in 1997?
Keep it short and to the point. 0.42. What is the ratio of the Taxes (in constant 2015 US$) in Bolivia in 1994 to that in 1995?
Offer a terse response. 0.81. What is the ratio of the Taxes (in constant 2015 US$) in Canada in 1994 to that in 1995?
Give a very brief answer. 0.95. What is the ratio of the Taxes (in constant 2015 US$) in Tanzania in 1994 to that in 1995?
Give a very brief answer. 0.87. What is the ratio of the Taxes (in constant 2015 US$) of Bolivia in 1994 to that in 1996?
Offer a terse response. 0.66. What is the ratio of the Taxes (in constant 2015 US$) of Canada in 1994 to that in 1996?
Make the answer very short. 0.92. What is the ratio of the Taxes (in constant 2015 US$) of Mauritius in 1994 to that in 1996?
Your answer should be very brief. 0.93. What is the ratio of the Taxes (in constant 2015 US$) in Tanzania in 1994 to that in 1996?
Your answer should be very brief. 0.63. What is the ratio of the Taxes (in constant 2015 US$) in Bolivia in 1994 to that in 1997?
Offer a very short reply. 0.61. What is the ratio of the Taxes (in constant 2015 US$) of Canada in 1994 to that in 1997?
Provide a succinct answer. 0.86. What is the ratio of the Taxes (in constant 2015 US$) of Mauritius in 1994 to that in 1997?
Offer a very short reply. 0.92. What is the ratio of the Taxes (in constant 2015 US$) in Tanzania in 1994 to that in 1997?
Your answer should be very brief. 0.49. What is the ratio of the Taxes (in constant 2015 US$) in Bolivia in 1995 to that in 1996?
Your answer should be compact. 0.81. What is the ratio of the Taxes (in constant 2015 US$) in Canada in 1995 to that in 1996?
Make the answer very short. 0.97. What is the ratio of the Taxes (in constant 2015 US$) in Mauritius in 1995 to that in 1996?
Your response must be concise. 0.94. What is the ratio of the Taxes (in constant 2015 US$) in Tanzania in 1995 to that in 1996?
Your answer should be very brief. 0.72. What is the ratio of the Taxes (in constant 2015 US$) of Bolivia in 1995 to that in 1997?
Provide a succinct answer. 0.75. What is the ratio of the Taxes (in constant 2015 US$) of Canada in 1995 to that in 1997?
Give a very brief answer. 0.91. What is the ratio of the Taxes (in constant 2015 US$) of Mauritius in 1995 to that in 1997?
Provide a short and direct response. 0.93. What is the ratio of the Taxes (in constant 2015 US$) of Tanzania in 1995 to that in 1997?
Ensure brevity in your answer.  0.57. What is the ratio of the Taxes (in constant 2015 US$) in Bolivia in 1996 to that in 1997?
Your answer should be very brief. 0.93. What is the ratio of the Taxes (in constant 2015 US$) in Canada in 1996 to that in 1997?
Offer a terse response. 0.94. What is the ratio of the Taxes (in constant 2015 US$) in Mauritius in 1996 to that in 1997?
Offer a terse response. 0.98. What is the ratio of the Taxes (in constant 2015 US$) in Tanzania in 1996 to that in 1997?
Offer a terse response. 0.79. What is the difference between the highest and the second highest Taxes (in constant 2015 US$) of Bolivia?
Make the answer very short. 7.73e+07. What is the difference between the highest and the second highest Taxes (in constant 2015 US$) in Canada?
Ensure brevity in your answer.  3.06e+09. What is the difference between the highest and the second highest Taxes (in constant 2015 US$) in Mauritius?
Your response must be concise. 7.79e+06. What is the difference between the highest and the second highest Taxes (in constant 2015 US$) in Tanzania?
Give a very brief answer. 1.46e+08. What is the difference between the highest and the lowest Taxes (in constant 2015 US$) in Bolivia?
Ensure brevity in your answer.  4.96e+08. What is the difference between the highest and the lowest Taxes (in constant 2015 US$) in Canada?
Your response must be concise. 6.49e+09. What is the difference between the highest and the lowest Taxes (in constant 2015 US$) in Mauritius?
Your answer should be compact. 4.88e+07. What is the difference between the highest and the lowest Taxes (in constant 2015 US$) in Tanzania?
Provide a short and direct response. 3.99e+08. 